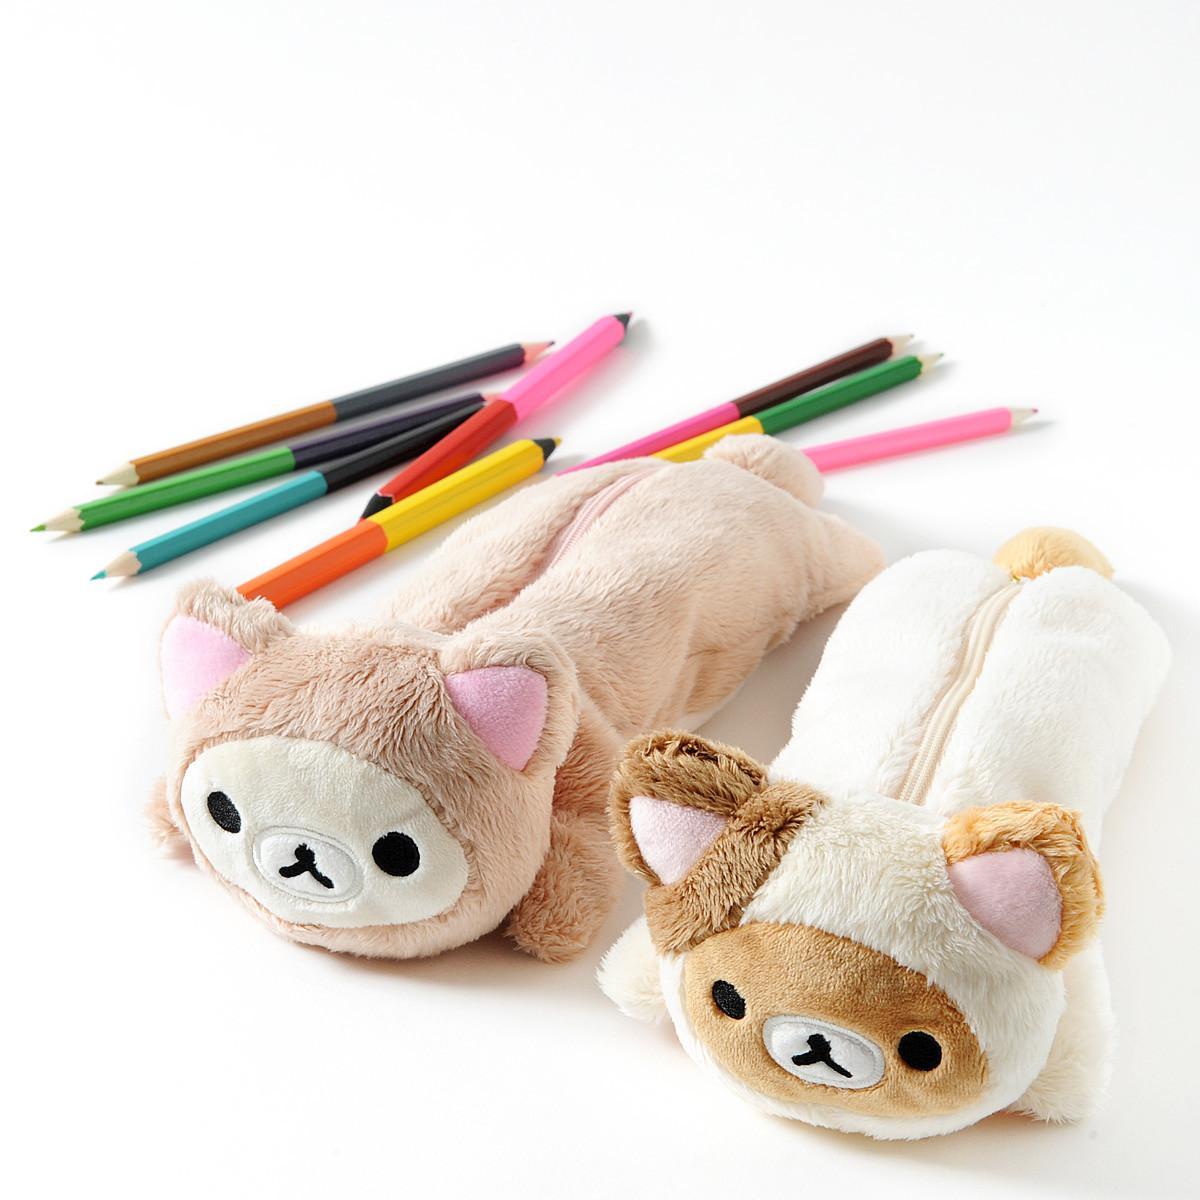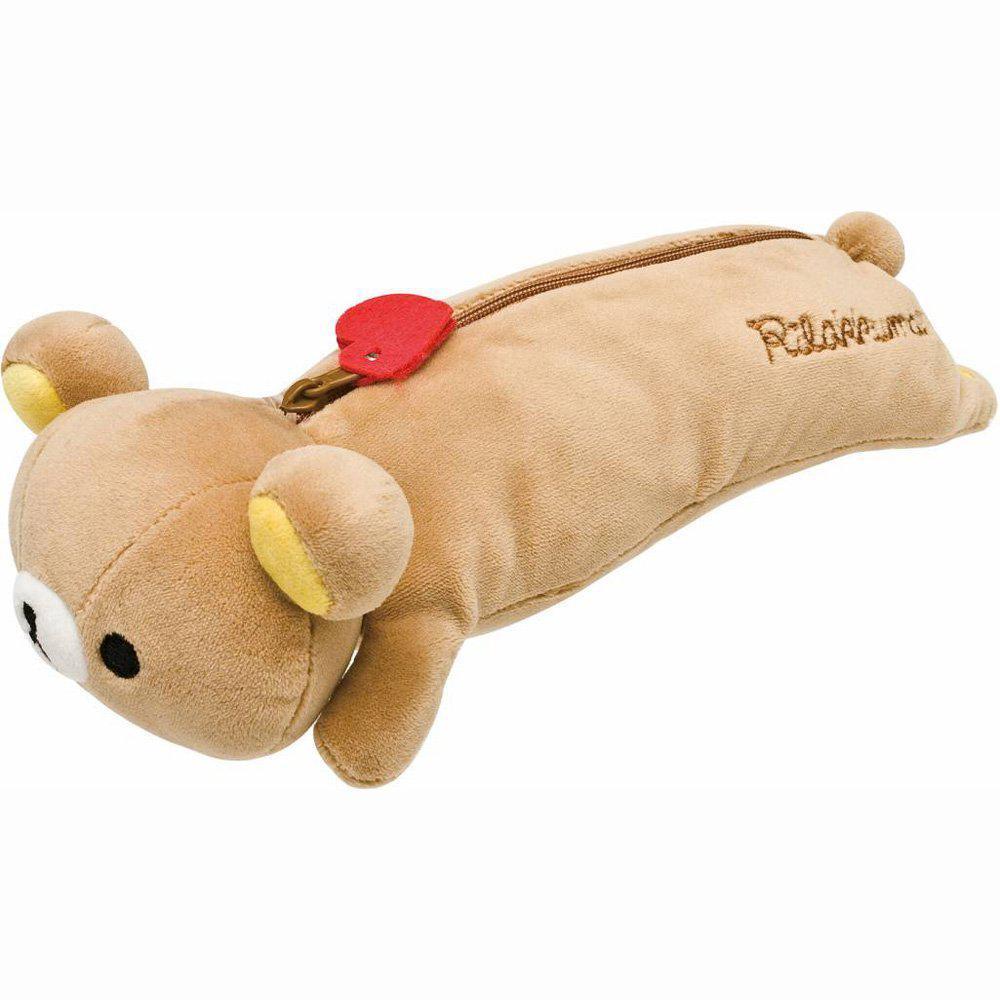The first image is the image on the left, the second image is the image on the right. For the images shown, is this caption "There is a plush teddy bear pencil case with a zipper facing to the left in both of the images." true? Answer yes or no. No. 